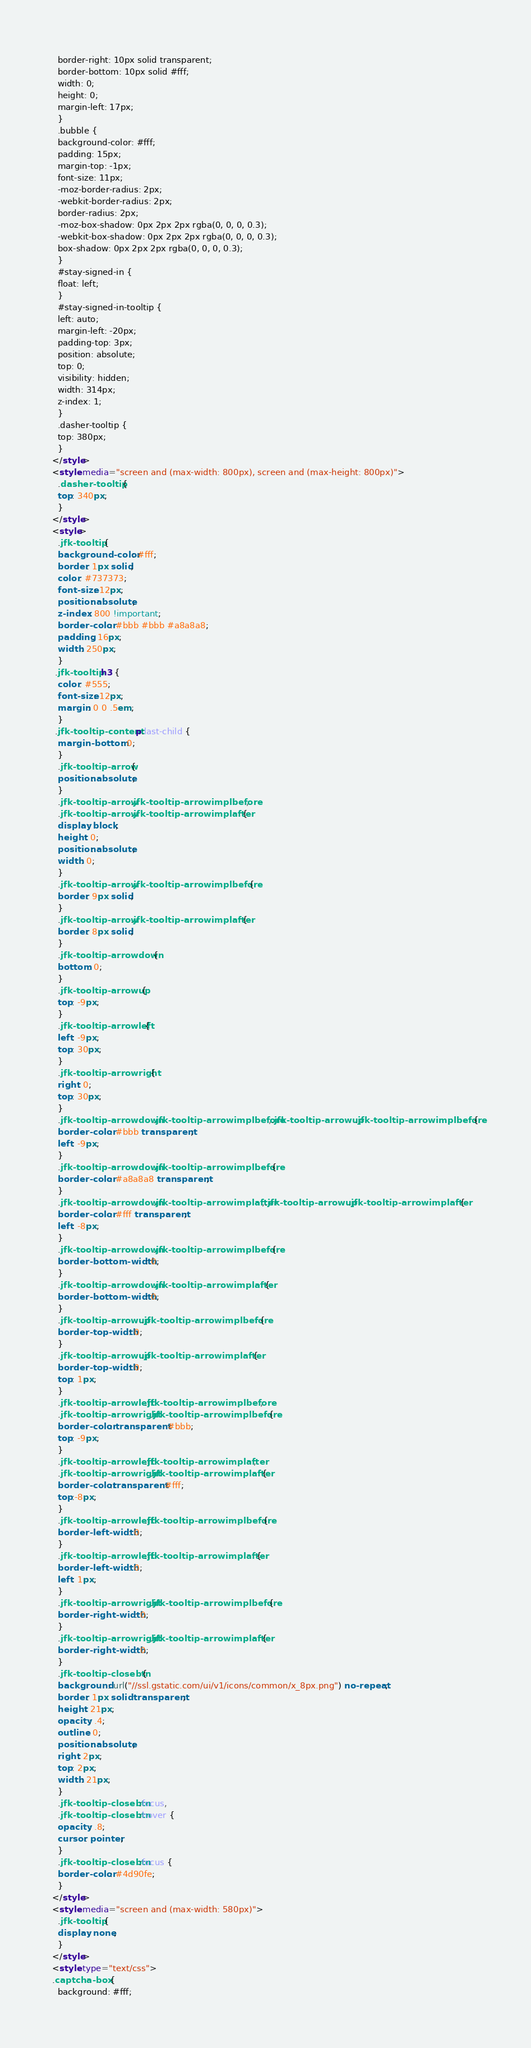Convert code to text. <code><loc_0><loc_0><loc_500><loc_500><_HTML_>  border-right: 10px solid transparent;
  border-bottom: 10px solid #fff;
  width: 0;
  height: 0;
  margin-left: 17px;
  }
  .bubble {
  background-color: #fff;
  padding: 15px;
  margin-top: -1px;
  font-size: 11px;
  -moz-border-radius: 2px;
  -webkit-border-radius: 2px;
  border-radius: 2px;
  -moz-box-shadow: 0px 2px 2px rgba(0, 0, 0, 0.3);
  -webkit-box-shadow: 0px 2px 2px rgba(0, 0, 0, 0.3);
  box-shadow: 0px 2px 2px rgba(0, 0, 0, 0.3);
  }
  #stay-signed-in {
  float: left;
  }
  #stay-signed-in-tooltip {
  left: auto;
  margin-left: -20px;
  padding-top: 3px;
  position: absolute;
  top: 0;
  visibility: hidden;
  width: 314px;
  z-index: 1;
  }
  .dasher-tooltip {
  top: 380px;
  }
</style>
<style media="screen and (max-width: 800px), screen and (max-height: 800px)">
  .dasher-tooltip {
  top: 340px;
  }
</style>
<style>
  .jfk-tooltip {
  background-color: #fff;
  border: 1px solid;
  color: #737373;
  font-size: 12px;
  position: absolute;
  z-index: 800 !important;
  border-color: #bbb #bbb #a8a8a8;
  padding: 16px;
  width: 250px;
  }
 .jfk-tooltip h3 {
  color: #555;
  font-size: 12px;
  margin: 0 0 .5em;
  }
 .jfk-tooltip-content p:last-child {
  margin-bottom: 0;
  }
  .jfk-tooltip-arrow {
  position: absolute;
  }
  .jfk-tooltip-arrow .jfk-tooltip-arrowimplbefore,
  .jfk-tooltip-arrow .jfk-tooltip-arrowimplafter {
  display: block;
  height: 0;
  position: absolute;
  width: 0;
  }
  .jfk-tooltip-arrow .jfk-tooltip-arrowimplbefore {
  border: 9px solid;
  }
  .jfk-tooltip-arrow .jfk-tooltip-arrowimplafter {
  border: 8px solid;
  }
  .jfk-tooltip-arrowdown {
  bottom: 0;
  }
  .jfk-tooltip-arrowup {
  top: -9px;
  }
  .jfk-tooltip-arrowleft {
  left: -9px;
  top: 30px;
  }
  .jfk-tooltip-arrowright {
  right: 0;
  top: 30px;
  }
  .jfk-tooltip-arrowdown .jfk-tooltip-arrowimplbefore,.jfk-tooltip-arrowup .jfk-tooltip-arrowimplbefore {
  border-color: #bbb transparent;
  left: -9px;
  }
  .jfk-tooltip-arrowdown .jfk-tooltip-arrowimplbefore {
  border-color: #a8a8a8 transparent;
  }
  .jfk-tooltip-arrowdown .jfk-tooltip-arrowimplafter,.jfk-tooltip-arrowup .jfk-tooltip-arrowimplafter {
  border-color: #fff transparent;
  left: -8px;
  }
  .jfk-tooltip-arrowdown .jfk-tooltip-arrowimplbefore {
  border-bottom-width: 0;
  }
  .jfk-tooltip-arrowdown .jfk-tooltip-arrowimplafter {
  border-bottom-width: 0;
  }
  .jfk-tooltip-arrowup .jfk-tooltip-arrowimplbefore {
  border-top-width: 0;
  }
  .jfk-tooltip-arrowup .jfk-tooltip-arrowimplafter {
  border-top-width: 0;
  top: 1px;
  }
  .jfk-tooltip-arrowleft .jfk-tooltip-arrowimplbefore,
  .jfk-tooltip-arrowright .jfk-tooltip-arrowimplbefore {
  border-color: transparent #bbb;
  top: -9px;
  }
  .jfk-tooltip-arrowleft .jfk-tooltip-arrowimplafter,
  .jfk-tooltip-arrowright .jfk-tooltip-arrowimplafter {
  border-color:transparent #fff;
  top:-8px;
  }
  .jfk-tooltip-arrowleft .jfk-tooltip-arrowimplbefore {
  border-left-width: 0;
  }
  .jfk-tooltip-arrowleft .jfk-tooltip-arrowimplafter {
  border-left-width: 0;
  left: 1px;
  }
  .jfk-tooltip-arrowright .jfk-tooltip-arrowimplbefore {
  border-right-width: 0;
  }
  .jfk-tooltip-arrowright .jfk-tooltip-arrowimplafter {
  border-right-width: 0;
  }
  .jfk-tooltip-closebtn {
  background: url("//ssl.gstatic.com/ui/v1/icons/common/x_8px.png") no-repeat;
  border: 1px solid transparent;
  height: 21px;
  opacity: .4;
  outline: 0;
  position: absolute;
  right: 2px;
  top: 2px;
  width: 21px;
  }
  .jfk-tooltip-closebtn:focus,
  .jfk-tooltip-closebtn:hover {
  opacity: .8;
  cursor: pointer;
  }
  .jfk-tooltip-closebtn:focus {
  border-color: #4d90fe;
  }
</style>
<style media="screen and (max-width: 580px)">
  .jfk-tooltip {
  display: none;
  }
</style>
<style type="text/css">
.captcha-box {
  background: #fff;</code> 